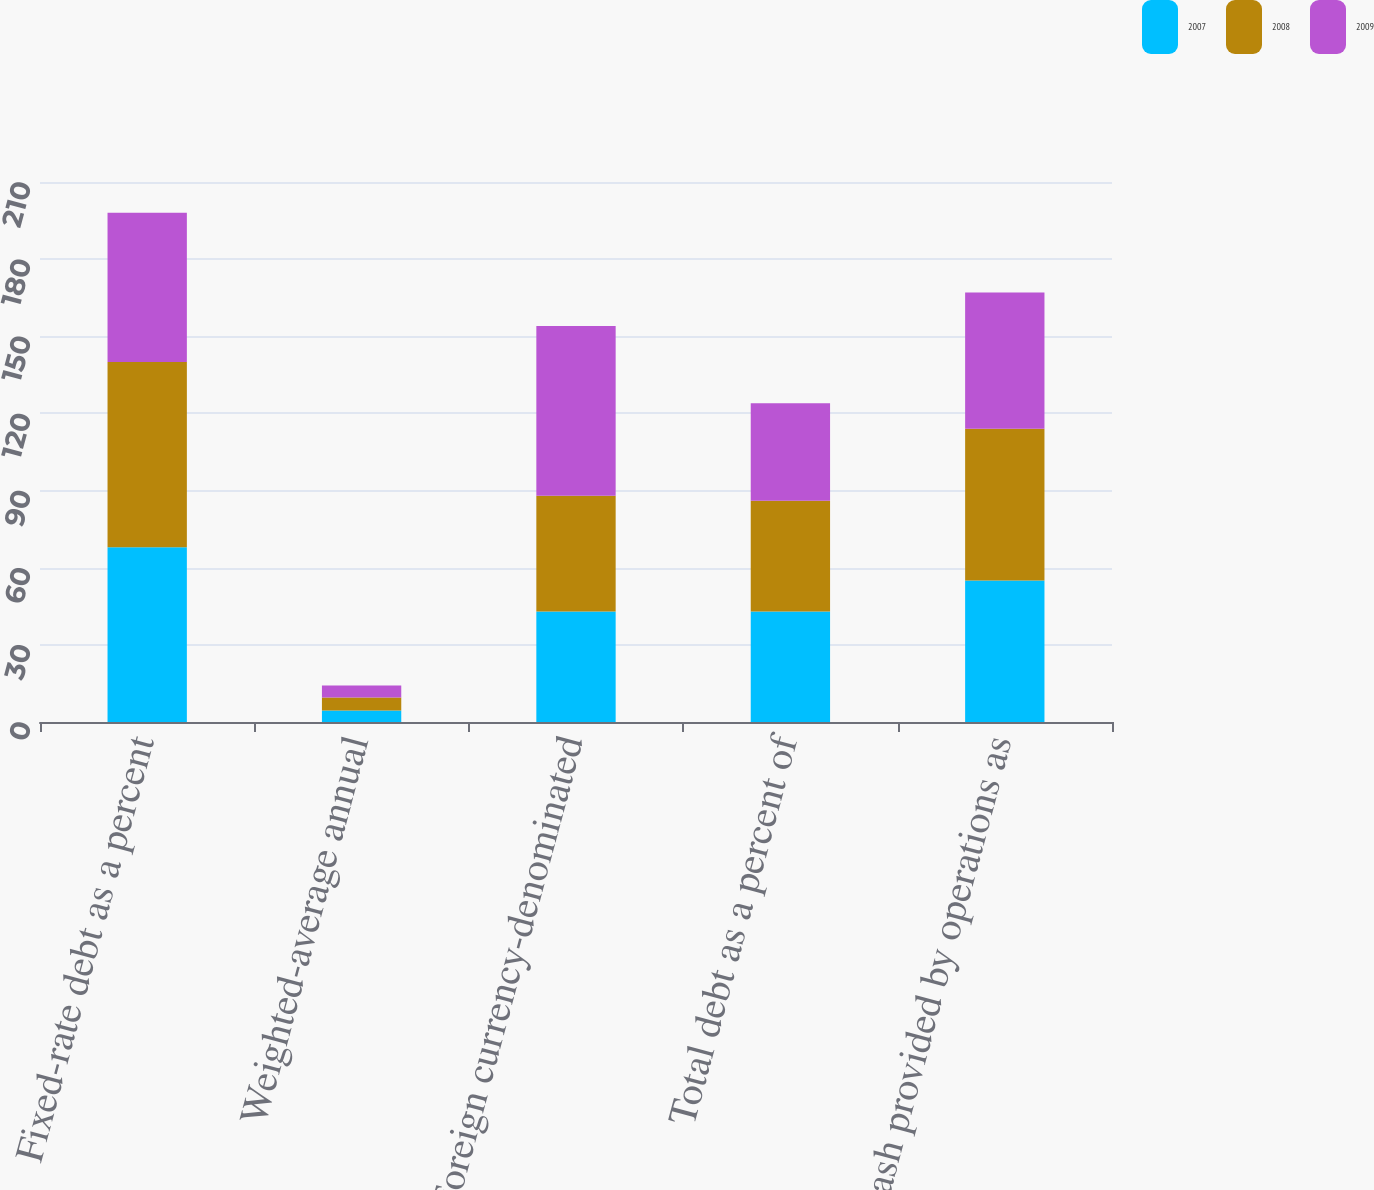Convert chart. <chart><loc_0><loc_0><loc_500><loc_500><stacked_bar_chart><ecel><fcel>Fixed-rate debt as a percent<fcel>Weighted-average annual<fcel>Foreign currency-denominated<fcel>Total debt as a percent of<fcel>Cash provided by operations as<nl><fcel>2007<fcel>68<fcel>4.5<fcel>43<fcel>43<fcel>55<nl><fcel>2008<fcel>72<fcel>5<fcel>45<fcel>43<fcel>59<nl><fcel>2009<fcel>58<fcel>4.7<fcel>66<fcel>38<fcel>53<nl></chart> 